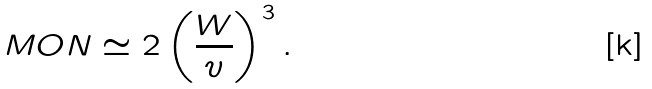<formula> <loc_0><loc_0><loc_500><loc_500>M O N \simeq 2 \left ( \frac { W } { v } \right ) ^ { 3 } .</formula> 